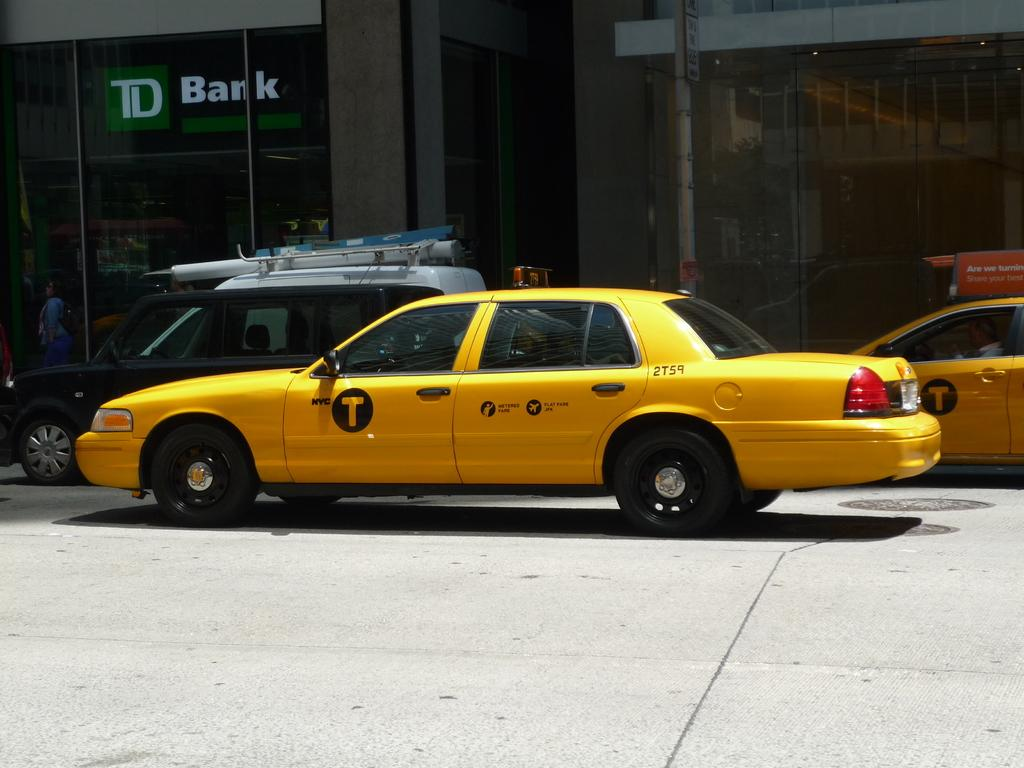<image>
Create a compact narrative representing the image presented. A yellow taxi says 2T59 on the back. 